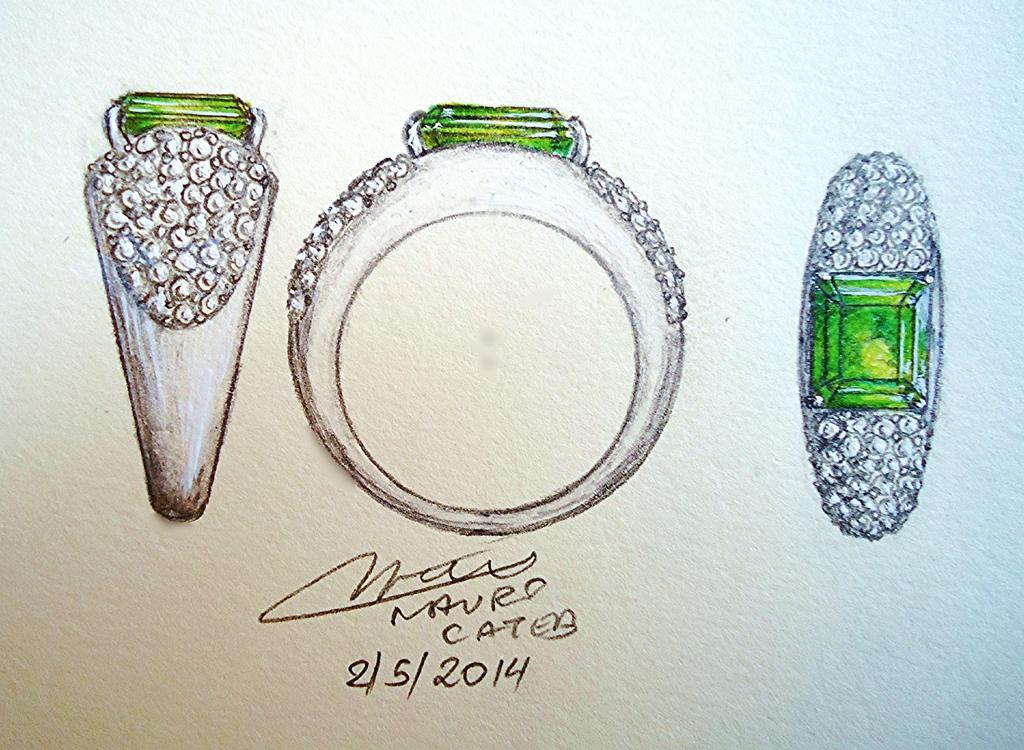Please provide a concise description of this image. In the picture there is a drawing of three rings with the green stone, on the poster there is some text. 